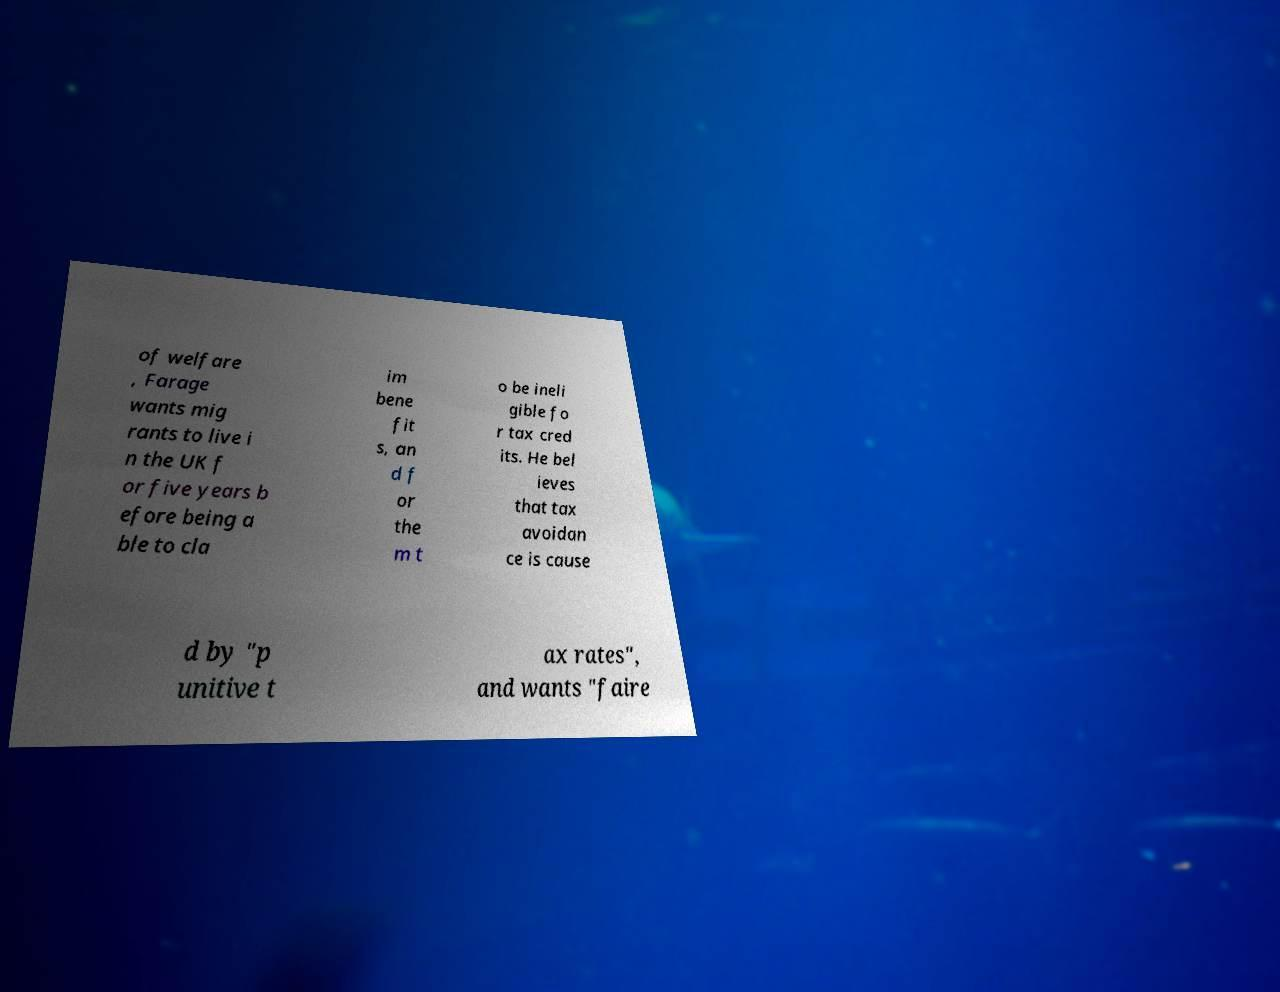Can you read and provide the text displayed in the image?This photo seems to have some interesting text. Can you extract and type it out for me? of welfare , Farage wants mig rants to live i n the UK f or five years b efore being a ble to cla im bene fit s, an d f or the m t o be ineli gible fo r tax cred its. He bel ieves that tax avoidan ce is cause d by "p unitive t ax rates", and wants "faire 